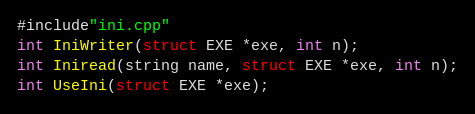<code> <loc_0><loc_0><loc_500><loc_500><_C_>#include"ini.cpp"
int IniWriter(struct EXE *exe, int n);
int Iniread(string name, struct EXE *exe, int n);
int UseIni(struct EXE *exe);</code> 